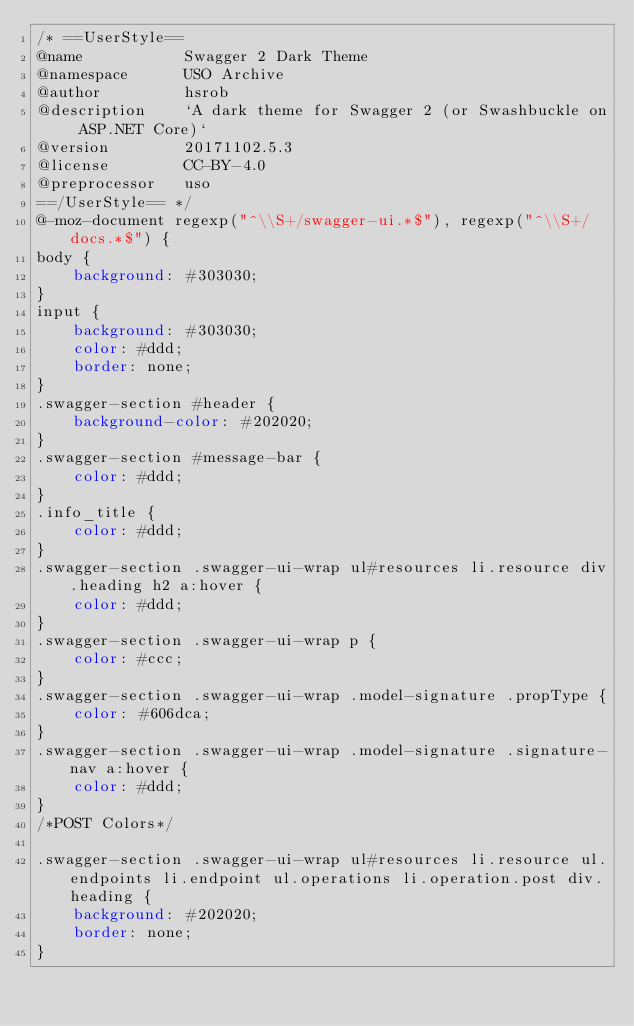<code> <loc_0><loc_0><loc_500><loc_500><_CSS_>/* ==UserStyle==
@name           Swagger 2 Dark Theme
@namespace      USO Archive
@author         hsrob
@description    `A dark theme for Swagger 2 (or Swashbuckle on ASP.NET Core)`
@version        20171102.5.3
@license        CC-BY-4.0
@preprocessor   uso
==/UserStyle== */
@-moz-document regexp("^\\S+/swagger-ui.*$"), regexp("^\\S+/docs.*$") {
body {
    background: #303030;
}
input {
    background: #303030;
    color: #ddd;
    border: none;
}
.swagger-section #header {
    background-color: #202020;
}
.swagger-section #message-bar {
    color: #ddd;
}
.info_title {
    color: #ddd;
}
.swagger-section .swagger-ui-wrap ul#resources li.resource div.heading h2 a:hover {
    color: #ddd;
}
.swagger-section .swagger-ui-wrap p {
    color: #ccc;
}
.swagger-section .swagger-ui-wrap .model-signature .propType {
    color: #606dca;
}
.swagger-section .swagger-ui-wrap .model-signature .signature-nav a:hover {
    color: #ddd;
}
/*POST Colors*/

.swagger-section .swagger-ui-wrap ul#resources li.resource ul.endpoints li.endpoint ul.operations li.operation.post div.heading {
    background: #202020;
    border: none;
}</code> 